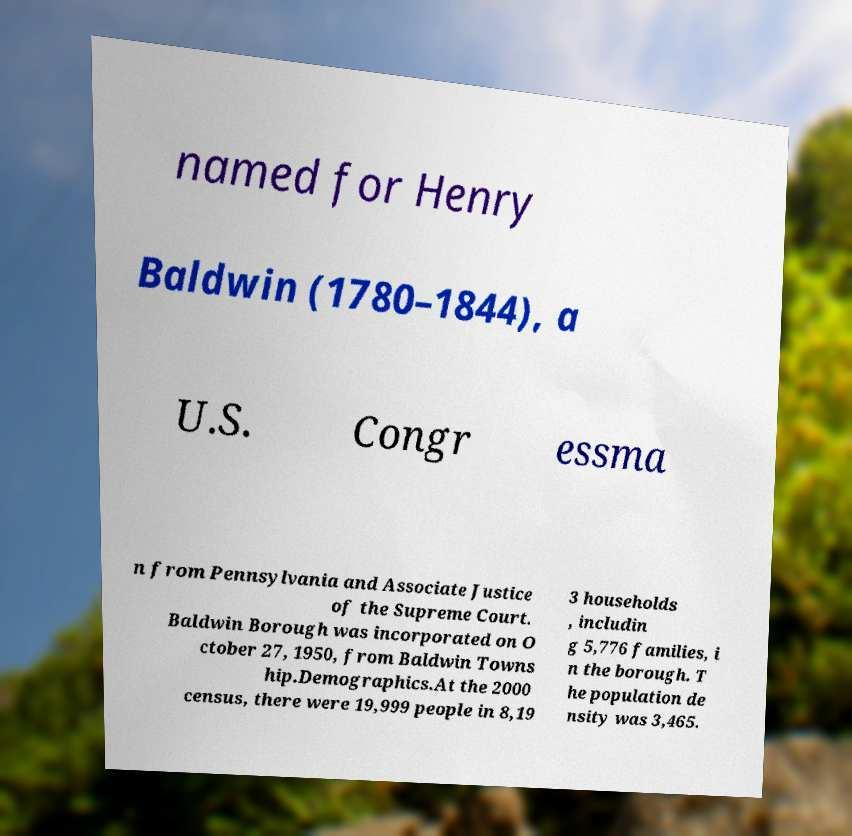I need the written content from this picture converted into text. Can you do that? named for Henry Baldwin (1780–1844), a U.S. Congr essma n from Pennsylvania and Associate Justice of the Supreme Court. Baldwin Borough was incorporated on O ctober 27, 1950, from Baldwin Towns hip.Demographics.At the 2000 census, there were 19,999 people in 8,19 3 households , includin g 5,776 families, i n the borough. T he population de nsity was 3,465. 